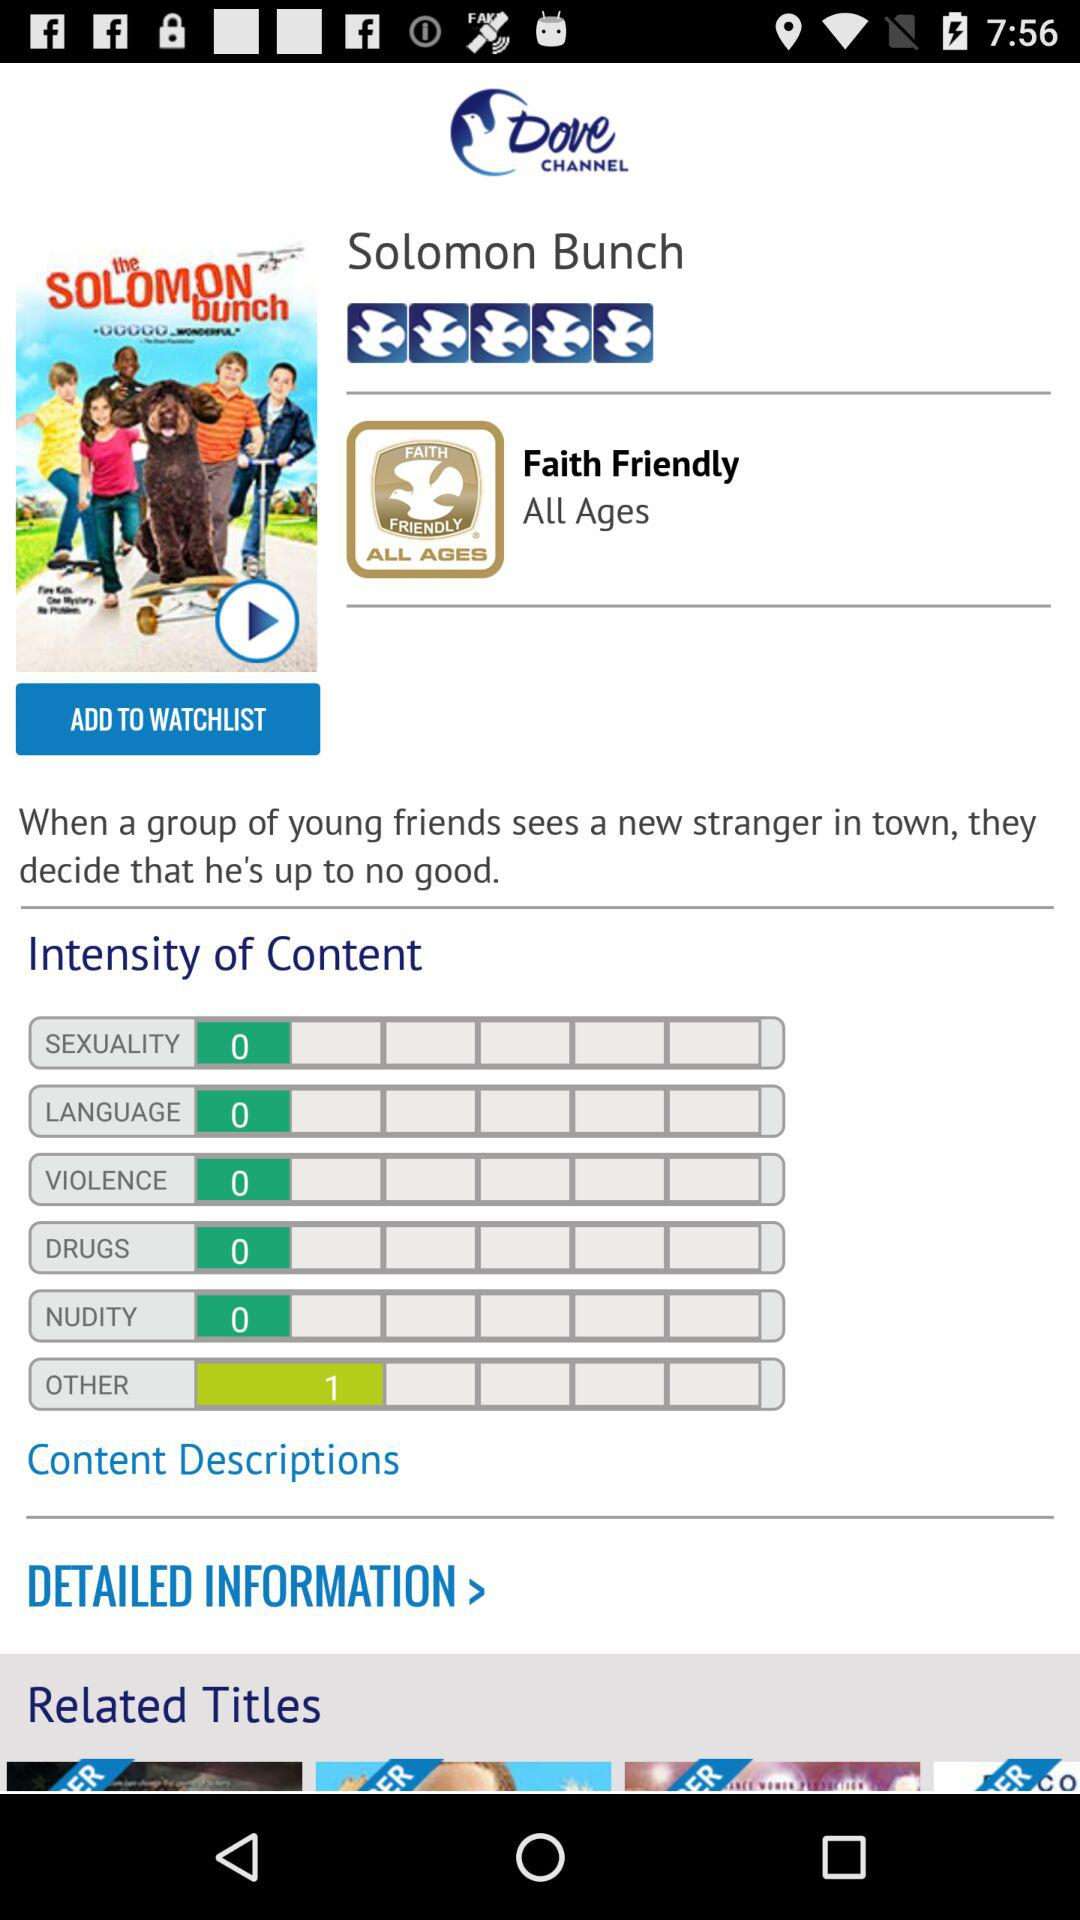What is the channel name? The channel name is "Dove Channel". 